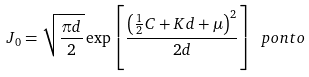<formula> <loc_0><loc_0><loc_500><loc_500>J _ { 0 } = \sqrt { \frac { \pi d } { 2 } } \exp \left [ \frac { \left ( \frac { 1 } { 2 } C + K d + \mu \right ) ^ { 2 } } { 2 d } \right ] \ p o n t o</formula> 